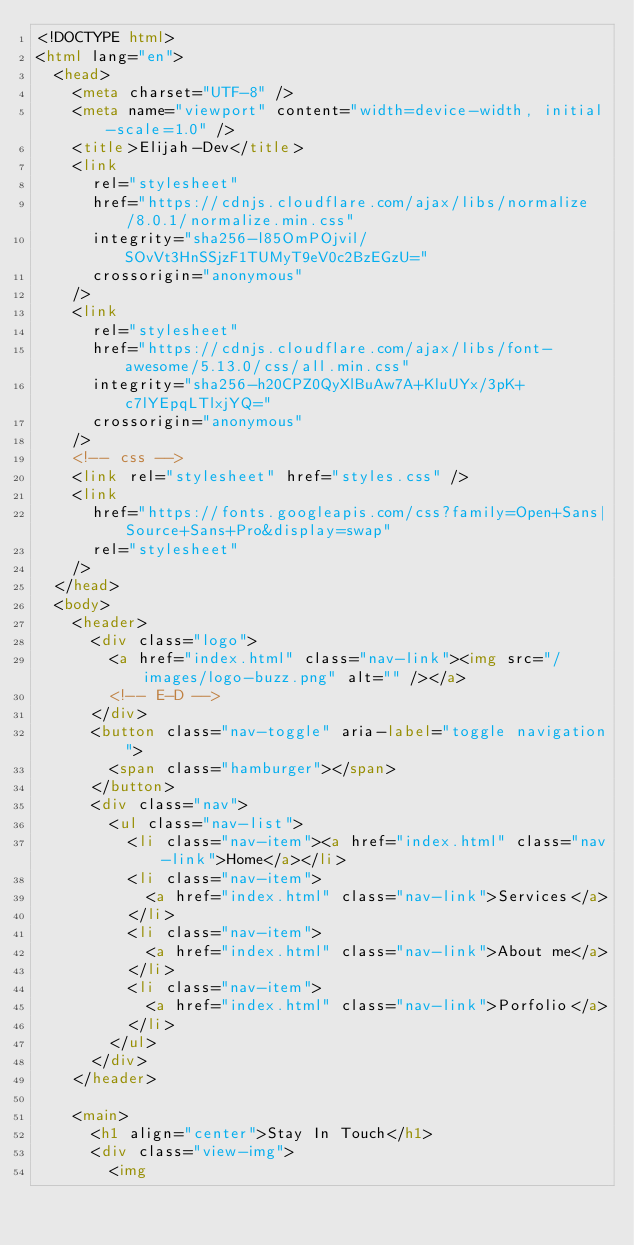<code> <loc_0><loc_0><loc_500><loc_500><_HTML_><!DOCTYPE html>
<html lang="en">
  <head>
    <meta charset="UTF-8" />
    <meta name="viewport" content="width=device-width, initial-scale=1.0" />
    <title>Elijah-Dev</title>
    <link
      rel="stylesheet"
      href="https://cdnjs.cloudflare.com/ajax/libs/normalize/8.0.1/normalize.min.css"
      integrity="sha256-l85OmPOjvil/SOvVt3HnSSjzF1TUMyT9eV0c2BzEGzU="
      crossorigin="anonymous"
    />
    <link
      rel="stylesheet"
      href="https://cdnjs.cloudflare.com/ajax/libs/font-awesome/5.13.0/css/all.min.css"
      integrity="sha256-h20CPZ0QyXlBuAw7A+KluUYx/3pK+c7lYEpqLTlxjYQ="
      crossorigin="anonymous"
    />
    <!-- css -->
    <link rel="stylesheet" href="styles.css" />
    <link
      href="https://fonts.googleapis.com/css?family=Open+Sans|Source+Sans+Pro&display=swap"
      rel="stylesheet"
    />
  </head>
  <body>
    <header>
      <div class="logo">
        <a href="index.html" class="nav-link"><img src="/images/logo-buzz.png" alt="" /></a>
        <!-- E-D -->
      </div>
      <button class="nav-toggle" aria-label="toggle navigation">
        <span class="hamburger"></span>
      </button>
      <div class="nav">
        <ul class="nav-list">
          <li class="nav-item"><a href="index.html" class="nav-link">Home</a></li>
          <li class="nav-item">
            <a href="index.html" class="nav-link">Services</a>
          </li>
          <li class="nav-item">
            <a href="index.html" class="nav-link">About me</a>
          </li>
          <li class="nav-item">
            <a href="index.html" class="nav-link">Porfolio</a>
          </li>
        </ul>
      </div>
    </header>

    <main>
      <h1 align="center">Stay In Touch</h1>
      <div class="view-img">
        <img</code> 